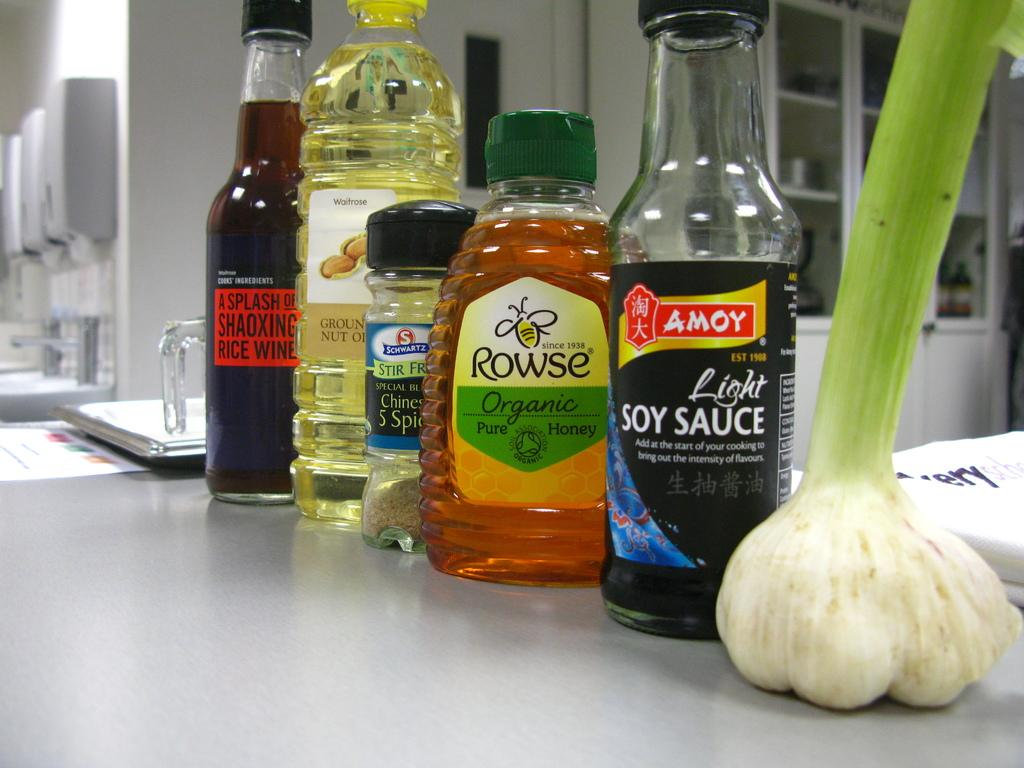How many types of bottles are in the image? There are five different types of bottles in the image. Where are the bottles placed? The bottles are placed on a table. What can be seen on the right side of the image? There is a vegetable on the right side of the image. What is visible in the background of the image? There is a wall in the background of the image. What type of key is being offered to the vegetable in the image? There is no key or offer present in the image; it only features bottles, a vegetable, and a wall in the background. 